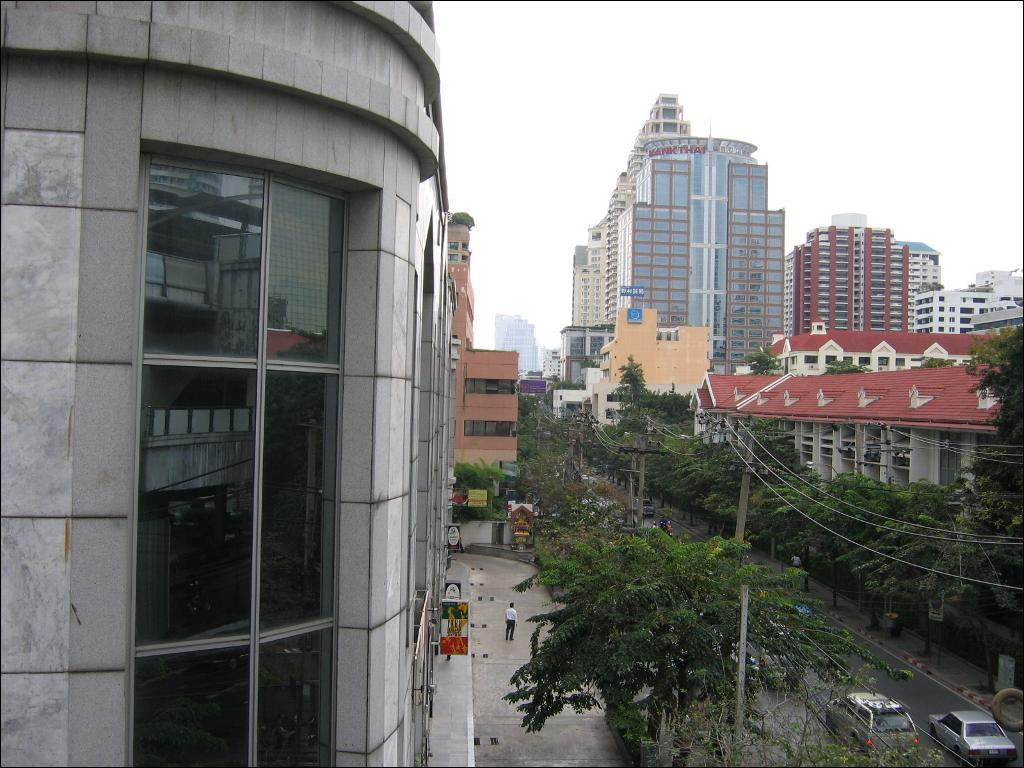What type of structures can be seen in the image? There are buildings in the image. What is happening on the road in the image? There are vehicles on the road in the image. What objects are visible in the image that are used for support or signage? There are poles visible in the image. What type of vegetation is present on either side of the road in the image? There are trees on either side of the road in the image. What is visible at the top of the image? The sky is visible at the top of the image. Where are the kittens playing in the image? There are no kittens present in the image. What riddle can be solved by looking at the image? The image does not contain any riddles to be solved. 